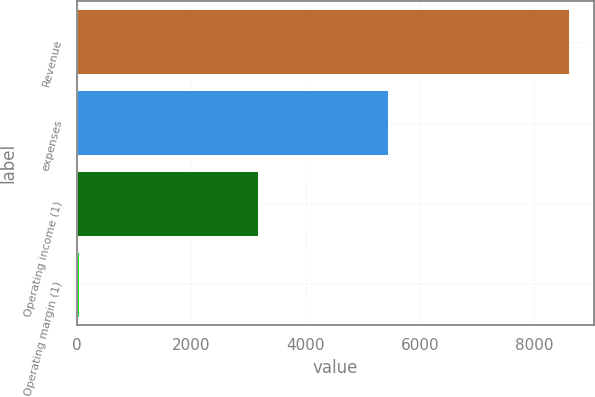<chart> <loc_0><loc_0><loc_500><loc_500><bar_chart><fcel>Revenue<fcel>expenses<fcel>Operating income (1)<fcel>Operating margin (1)<nl><fcel>8612<fcel>5445<fcel>3167<fcel>39.3<nl></chart> 